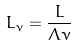Convert formula to latex. <formula><loc_0><loc_0><loc_500><loc_500>L _ { \nu } = \frac { L } { \Lambda \nu }</formula> 